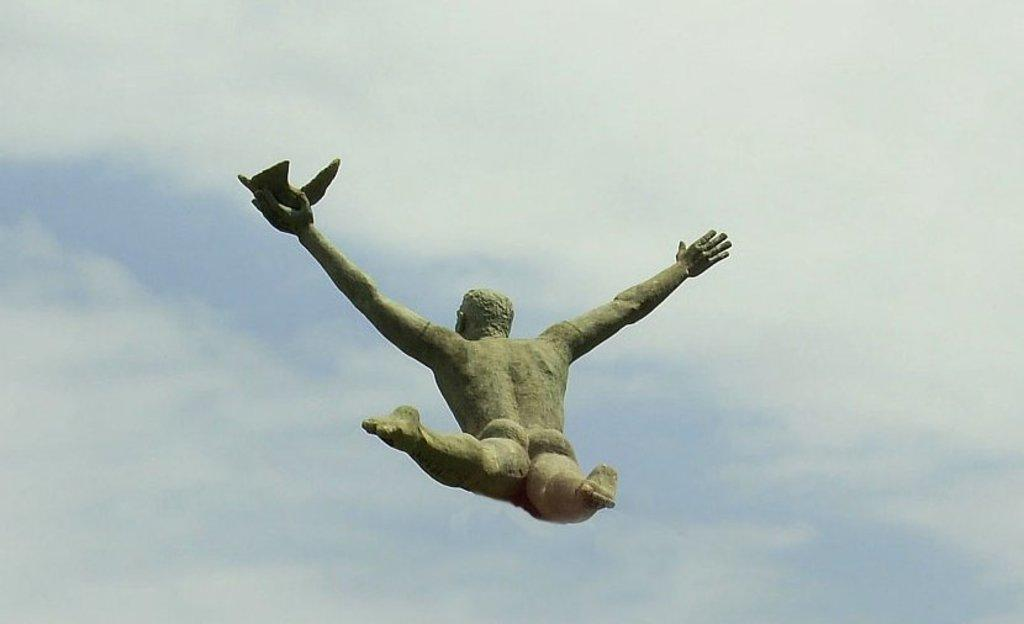What is the main subject of the image? There is a statue of a man in the image. Can you describe the statue's surroundings? The statue is in front of a cloudy sky. What type of power does the man in the statue possess? There is no indication in the image of the man possessing any power, as it is a statue. How much salt is visible in the image? There is no salt present in the image. 